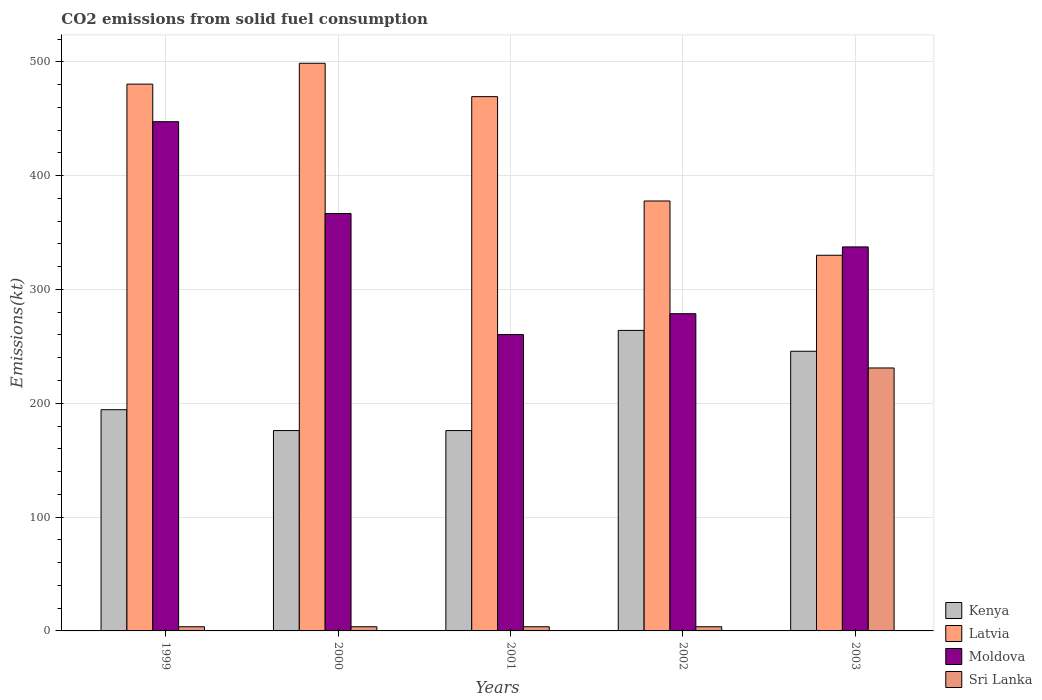Are the number of bars on each tick of the X-axis equal?
Offer a terse response. Yes. What is the label of the 5th group of bars from the left?
Provide a short and direct response. 2003. What is the amount of CO2 emitted in Kenya in 2001?
Make the answer very short. 176.02. Across all years, what is the maximum amount of CO2 emitted in Moldova?
Offer a terse response. 447.37. Across all years, what is the minimum amount of CO2 emitted in Latvia?
Keep it short and to the point. 330.03. In which year was the amount of CO2 emitted in Kenya maximum?
Your answer should be very brief. 2002. In which year was the amount of CO2 emitted in Kenya minimum?
Give a very brief answer. 2000. What is the total amount of CO2 emitted in Sri Lanka in the graph?
Provide a succinct answer. 245.69. What is the difference between the amount of CO2 emitted in Moldova in 2001 and that in 2003?
Your answer should be very brief. -77.01. What is the difference between the amount of CO2 emitted in Moldova in 2000 and the amount of CO2 emitted in Kenya in 2003?
Offer a terse response. 121.01. What is the average amount of CO2 emitted in Sri Lanka per year?
Give a very brief answer. 49.14. In the year 1999, what is the difference between the amount of CO2 emitted in Moldova and amount of CO2 emitted in Latvia?
Give a very brief answer. -33. What is the ratio of the amount of CO2 emitted in Moldova in 1999 to that in 2002?
Your answer should be compact. 1.61. What is the difference between the highest and the second highest amount of CO2 emitted in Kenya?
Offer a terse response. 18.34. What is the difference between the highest and the lowest amount of CO2 emitted in Sri Lanka?
Your answer should be very brief. 227.35. Is the sum of the amount of CO2 emitted in Moldova in 2002 and 2003 greater than the maximum amount of CO2 emitted in Kenya across all years?
Give a very brief answer. Yes. What does the 2nd bar from the left in 2002 represents?
Offer a very short reply. Latvia. What does the 2nd bar from the right in 2001 represents?
Keep it short and to the point. Moldova. Is it the case that in every year, the sum of the amount of CO2 emitted in Latvia and amount of CO2 emitted in Moldova is greater than the amount of CO2 emitted in Sri Lanka?
Your response must be concise. Yes. Are all the bars in the graph horizontal?
Offer a very short reply. No. What is the difference between two consecutive major ticks on the Y-axis?
Offer a terse response. 100. Are the values on the major ticks of Y-axis written in scientific E-notation?
Keep it short and to the point. No. What is the title of the graph?
Provide a short and direct response. CO2 emissions from solid fuel consumption. What is the label or title of the Y-axis?
Your answer should be very brief. Emissions(kt). What is the Emissions(kt) of Kenya in 1999?
Your response must be concise. 194.35. What is the Emissions(kt) in Latvia in 1999?
Offer a terse response. 480.38. What is the Emissions(kt) of Moldova in 1999?
Give a very brief answer. 447.37. What is the Emissions(kt) of Sri Lanka in 1999?
Offer a very short reply. 3.67. What is the Emissions(kt) of Kenya in 2000?
Provide a short and direct response. 176.02. What is the Emissions(kt) in Latvia in 2000?
Provide a succinct answer. 498.71. What is the Emissions(kt) in Moldova in 2000?
Give a very brief answer. 366.7. What is the Emissions(kt) in Sri Lanka in 2000?
Offer a terse response. 3.67. What is the Emissions(kt) of Kenya in 2001?
Offer a terse response. 176.02. What is the Emissions(kt) in Latvia in 2001?
Keep it short and to the point. 469.38. What is the Emissions(kt) in Moldova in 2001?
Offer a terse response. 260.36. What is the Emissions(kt) of Sri Lanka in 2001?
Give a very brief answer. 3.67. What is the Emissions(kt) of Kenya in 2002?
Keep it short and to the point. 264.02. What is the Emissions(kt) of Latvia in 2002?
Offer a terse response. 377.7. What is the Emissions(kt) of Moldova in 2002?
Offer a terse response. 278.69. What is the Emissions(kt) in Sri Lanka in 2002?
Give a very brief answer. 3.67. What is the Emissions(kt) in Kenya in 2003?
Provide a short and direct response. 245.69. What is the Emissions(kt) of Latvia in 2003?
Ensure brevity in your answer.  330.03. What is the Emissions(kt) in Moldova in 2003?
Provide a short and direct response. 337.36. What is the Emissions(kt) of Sri Lanka in 2003?
Provide a succinct answer. 231.02. Across all years, what is the maximum Emissions(kt) in Kenya?
Offer a very short reply. 264.02. Across all years, what is the maximum Emissions(kt) of Latvia?
Make the answer very short. 498.71. Across all years, what is the maximum Emissions(kt) in Moldova?
Keep it short and to the point. 447.37. Across all years, what is the maximum Emissions(kt) of Sri Lanka?
Offer a very short reply. 231.02. Across all years, what is the minimum Emissions(kt) of Kenya?
Give a very brief answer. 176.02. Across all years, what is the minimum Emissions(kt) of Latvia?
Offer a terse response. 330.03. Across all years, what is the minimum Emissions(kt) of Moldova?
Give a very brief answer. 260.36. Across all years, what is the minimum Emissions(kt) of Sri Lanka?
Make the answer very short. 3.67. What is the total Emissions(kt) of Kenya in the graph?
Offer a very short reply. 1056.1. What is the total Emissions(kt) of Latvia in the graph?
Make the answer very short. 2156.2. What is the total Emissions(kt) in Moldova in the graph?
Offer a terse response. 1690.49. What is the total Emissions(kt) in Sri Lanka in the graph?
Ensure brevity in your answer.  245.69. What is the difference between the Emissions(kt) of Kenya in 1999 and that in 2000?
Make the answer very short. 18.34. What is the difference between the Emissions(kt) of Latvia in 1999 and that in 2000?
Give a very brief answer. -18.34. What is the difference between the Emissions(kt) in Moldova in 1999 and that in 2000?
Your answer should be compact. 80.67. What is the difference between the Emissions(kt) of Kenya in 1999 and that in 2001?
Give a very brief answer. 18.34. What is the difference between the Emissions(kt) in Latvia in 1999 and that in 2001?
Ensure brevity in your answer.  11. What is the difference between the Emissions(kt) in Moldova in 1999 and that in 2001?
Your response must be concise. 187.02. What is the difference between the Emissions(kt) in Kenya in 1999 and that in 2002?
Provide a short and direct response. -69.67. What is the difference between the Emissions(kt) of Latvia in 1999 and that in 2002?
Offer a terse response. 102.68. What is the difference between the Emissions(kt) of Moldova in 1999 and that in 2002?
Ensure brevity in your answer.  168.68. What is the difference between the Emissions(kt) in Sri Lanka in 1999 and that in 2002?
Provide a succinct answer. 0. What is the difference between the Emissions(kt) in Kenya in 1999 and that in 2003?
Keep it short and to the point. -51.34. What is the difference between the Emissions(kt) of Latvia in 1999 and that in 2003?
Your response must be concise. 150.35. What is the difference between the Emissions(kt) in Moldova in 1999 and that in 2003?
Offer a terse response. 110.01. What is the difference between the Emissions(kt) in Sri Lanka in 1999 and that in 2003?
Your answer should be compact. -227.35. What is the difference between the Emissions(kt) of Latvia in 2000 and that in 2001?
Give a very brief answer. 29.34. What is the difference between the Emissions(kt) in Moldova in 2000 and that in 2001?
Provide a short and direct response. 106.34. What is the difference between the Emissions(kt) in Kenya in 2000 and that in 2002?
Offer a terse response. -88.01. What is the difference between the Emissions(kt) in Latvia in 2000 and that in 2002?
Your answer should be very brief. 121.01. What is the difference between the Emissions(kt) of Moldova in 2000 and that in 2002?
Offer a very short reply. 88.01. What is the difference between the Emissions(kt) in Sri Lanka in 2000 and that in 2002?
Your response must be concise. 0. What is the difference between the Emissions(kt) in Kenya in 2000 and that in 2003?
Your answer should be very brief. -69.67. What is the difference between the Emissions(kt) in Latvia in 2000 and that in 2003?
Your response must be concise. 168.68. What is the difference between the Emissions(kt) of Moldova in 2000 and that in 2003?
Your answer should be compact. 29.34. What is the difference between the Emissions(kt) of Sri Lanka in 2000 and that in 2003?
Give a very brief answer. -227.35. What is the difference between the Emissions(kt) of Kenya in 2001 and that in 2002?
Keep it short and to the point. -88.01. What is the difference between the Emissions(kt) of Latvia in 2001 and that in 2002?
Your response must be concise. 91.67. What is the difference between the Emissions(kt) of Moldova in 2001 and that in 2002?
Give a very brief answer. -18.34. What is the difference between the Emissions(kt) of Kenya in 2001 and that in 2003?
Make the answer very short. -69.67. What is the difference between the Emissions(kt) of Latvia in 2001 and that in 2003?
Offer a terse response. 139.35. What is the difference between the Emissions(kt) in Moldova in 2001 and that in 2003?
Your response must be concise. -77.01. What is the difference between the Emissions(kt) of Sri Lanka in 2001 and that in 2003?
Your answer should be compact. -227.35. What is the difference between the Emissions(kt) in Kenya in 2002 and that in 2003?
Provide a succinct answer. 18.34. What is the difference between the Emissions(kt) in Latvia in 2002 and that in 2003?
Provide a short and direct response. 47.67. What is the difference between the Emissions(kt) in Moldova in 2002 and that in 2003?
Make the answer very short. -58.67. What is the difference between the Emissions(kt) in Sri Lanka in 2002 and that in 2003?
Your answer should be very brief. -227.35. What is the difference between the Emissions(kt) of Kenya in 1999 and the Emissions(kt) of Latvia in 2000?
Provide a short and direct response. -304.36. What is the difference between the Emissions(kt) of Kenya in 1999 and the Emissions(kt) of Moldova in 2000?
Offer a terse response. -172.35. What is the difference between the Emissions(kt) of Kenya in 1999 and the Emissions(kt) of Sri Lanka in 2000?
Ensure brevity in your answer.  190.68. What is the difference between the Emissions(kt) of Latvia in 1999 and the Emissions(kt) of Moldova in 2000?
Offer a terse response. 113.68. What is the difference between the Emissions(kt) of Latvia in 1999 and the Emissions(kt) of Sri Lanka in 2000?
Provide a short and direct response. 476.71. What is the difference between the Emissions(kt) in Moldova in 1999 and the Emissions(kt) in Sri Lanka in 2000?
Give a very brief answer. 443.71. What is the difference between the Emissions(kt) of Kenya in 1999 and the Emissions(kt) of Latvia in 2001?
Ensure brevity in your answer.  -275.02. What is the difference between the Emissions(kt) of Kenya in 1999 and the Emissions(kt) of Moldova in 2001?
Your answer should be very brief. -66.01. What is the difference between the Emissions(kt) of Kenya in 1999 and the Emissions(kt) of Sri Lanka in 2001?
Your answer should be very brief. 190.68. What is the difference between the Emissions(kt) of Latvia in 1999 and the Emissions(kt) of Moldova in 2001?
Offer a terse response. 220.02. What is the difference between the Emissions(kt) of Latvia in 1999 and the Emissions(kt) of Sri Lanka in 2001?
Provide a succinct answer. 476.71. What is the difference between the Emissions(kt) of Moldova in 1999 and the Emissions(kt) of Sri Lanka in 2001?
Make the answer very short. 443.71. What is the difference between the Emissions(kt) of Kenya in 1999 and the Emissions(kt) of Latvia in 2002?
Offer a terse response. -183.35. What is the difference between the Emissions(kt) of Kenya in 1999 and the Emissions(kt) of Moldova in 2002?
Ensure brevity in your answer.  -84.34. What is the difference between the Emissions(kt) of Kenya in 1999 and the Emissions(kt) of Sri Lanka in 2002?
Ensure brevity in your answer.  190.68. What is the difference between the Emissions(kt) of Latvia in 1999 and the Emissions(kt) of Moldova in 2002?
Offer a very short reply. 201.69. What is the difference between the Emissions(kt) of Latvia in 1999 and the Emissions(kt) of Sri Lanka in 2002?
Your response must be concise. 476.71. What is the difference between the Emissions(kt) in Moldova in 1999 and the Emissions(kt) in Sri Lanka in 2002?
Make the answer very short. 443.71. What is the difference between the Emissions(kt) in Kenya in 1999 and the Emissions(kt) in Latvia in 2003?
Ensure brevity in your answer.  -135.68. What is the difference between the Emissions(kt) in Kenya in 1999 and the Emissions(kt) in Moldova in 2003?
Offer a very short reply. -143.01. What is the difference between the Emissions(kt) in Kenya in 1999 and the Emissions(kt) in Sri Lanka in 2003?
Your response must be concise. -36.67. What is the difference between the Emissions(kt) in Latvia in 1999 and the Emissions(kt) in Moldova in 2003?
Make the answer very short. 143.01. What is the difference between the Emissions(kt) in Latvia in 1999 and the Emissions(kt) in Sri Lanka in 2003?
Keep it short and to the point. 249.36. What is the difference between the Emissions(kt) of Moldova in 1999 and the Emissions(kt) of Sri Lanka in 2003?
Your answer should be very brief. 216.35. What is the difference between the Emissions(kt) in Kenya in 2000 and the Emissions(kt) in Latvia in 2001?
Your answer should be compact. -293.36. What is the difference between the Emissions(kt) in Kenya in 2000 and the Emissions(kt) in Moldova in 2001?
Provide a short and direct response. -84.34. What is the difference between the Emissions(kt) in Kenya in 2000 and the Emissions(kt) in Sri Lanka in 2001?
Your answer should be very brief. 172.35. What is the difference between the Emissions(kt) of Latvia in 2000 and the Emissions(kt) of Moldova in 2001?
Your response must be concise. 238.35. What is the difference between the Emissions(kt) of Latvia in 2000 and the Emissions(kt) of Sri Lanka in 2001?
Your response must be concise. 495.05. What is the difference between the Emissions(kt) in Moldova in 2000 and the Emissions(kt) in Sri Lanka in 2001?
Your response must be concise. 363.03. What is the difference between the Emissions(kt) of Kenya in 2000 and the Emissions(kt) of Latvia in 2002?
Make the answer very short. -201.69. What is the difference between the Emissions(kt) in Kenya in 2000 and the Emissions(kt) in Moldova in 2002?
Offer a terse response. -102.68. What is the difference between the Emissions(kt) in Kenya in 2000 and the Emissions(kt) in Sri Lanka in 2002?
Your answer should be compact. 172.35. What is the difference between the Emissions(kt) of Latvia in 2000 and the Emissions(kt) of Moldova in 2002?
Give a very brief answer. 220.02. What is the difference between the Emissions(kt) in Latvia in 2000 and the Emissions(kt) in Sri Lanka in 2002?
Make the answer very short. 495.05. What is the difference between the Emissions(kt) in Moldova in 2000 and the Emissions(kt) in Sri Lanka in 2002?
Your answer should be compact. 363.03. What is the difference between the Emissions(kt) in Kenya in 2000 and the Emissions(kt) in Latvia in 2003?
Ensure brevity in your answer.  -154.01. What is the difference between the Emissions(kt) of Kenya in 2000 and the Emissions(kt) of Moldova in 2003?
Give a very brief answer. -161.35. What is the difference between the Emissions(kt) of Kenya in 2000 and the Emissions(kt) of Sri Lanka in 2003?
Your response must be concise. -55.01. What is the difference between the Emissions(kt) of Latvia in 2000 and the Emissions(kt) of Moldova in 2003?
Give a very brief answer. 161.35. What is the difference between the Emissions(kt) in Latvia in 2000 and the Emissions(kt) in Sri Lanka in 2003?
Make the answer very short. 267.69. What is the difference between the Emissions(kt) of Moldova in 2000 and the Emissions(kt) of Sri Lanka in 2003?
Keep it short and to the point. 135.68. What is the difference between the Emissions(kt) of Kenya in 2001 and the Emissions(kt) of Latvia in 2002?
Offer a very short reply. -201.69. What is the difference between the Emissions(kt) of Kenya in 2001 and the Emissions(kt) of Moldova in 2002?
Provide a short and direct response. -102.68. What is the difference between the Emissions(kt) of Kenya in 2001 and the Emissions(kt) of Sri Lanka in 2002?
Make the answer very short. 172.35. What is the difference between the Emissions(kt) of Latvia in 2001 and the Emissions(kt) of Moldova in 2002?
Your answer should be very brief. 190.68. What is the difference between the Emissions(kt) of Latvia in 2001 and the Emissions(kt) of Sri Lanka in 2002?
Provide a succinct answer. 465.71. What is the difference between the Emissions(kt) of Moldova in 2001 and the Emissions(kt) of Sri Lanka in 2002?
Keep it short and to the point. 256.69. What is the difference between the Emissions(kt) in Kenya in 2001 and the Emissions(kt) in Latvia in 2003?
Provide a short and direct response. -154.01. What is the difference between the Emissions(kt) in Kenya in 2001 and the Emissions(kt) in Moldova in 2003?
Give a very brief answer. -161.35. What is the difference between the Emissions(kt) in Kenya in 2001 and the Emissions(kt) in Sri Lanka in 2003?
Make the answer very short. -55.01. What is the difference between the Emissions(kt) in Latvia in 2001 and the Emissions(kt) in Moldova in 2003?
Your response must be concise. 132.01. What is the difference between the Emissions(kt) in Latvia in 2001 and the Emissions(kt) in Sri Lanka in 2003?
Give a very brief answer. 238.35. What is the difference between the Emissions(kt) in Moldova in 2001 and the Emissions(kt) in Sri Lanka in 2003?
Provide a succinct answer. 29.34. What is the difference between the Emissions(kt) in Kenya in 2002 and the Emissions(kt) in Latvia in 2003?
Offer a terse response. -66.01. What is the difference between the Emissions(kt) in Kenya in 2002 and the Emissions(kt) in Moldova in 2003?
Offer a very short reply. -73.34. What is the difference between the Emissions(kt) in Kenya in 2002 and the Emissions(kt) in Sri Lanka in 2003?
Ensure brevity in your answer.  33. What is the difference between the Emissions(kt) of Latvia in 2002 and the Emissions(kt) of Moldova in 2003?
Your answer should be compact. 40.34. What is the difference between the Emissions(kt) of Latvia in 2002 and the Emissions(kt) of Sri Lanka in 2003?
Your response must be concise. 146.68. What is the difference between the Emissions(kt) of Moldova in 2002 and the Emissions(kt) of Sri Lanka in 2003?
Keep it short and to the point. 47.67. What is the average Emissions(kt) of Kenya per year?
Your response must be concise. 211.22. What is the average Emissions(kt) of Latvia per year?
Make the answer very short. 431.24. What is the average Emissions(kt) in Moldova per year?
Keep it short and to the point. 338.1. What is the average Emissions(kt) in Sri Lanka per year?
Ensure brevity in your answer.  49.14. In the year 1999, what is the difference between the Emissions(kt) in Kenya and Emissions(kt) in Latvia?
Ensure brevity in your answer.  -286.03. In the year 1999, what is the difference between the Emissions(kt) of Kenya and Emissions(kt) of Moldova?
Your answer should be compact. -253.02. In the year 1999, what is the difference between the Emissions(kt) of Kenya and Emissions(kt) of Sri Lanka?
Your response must be concise. 190.68. In the year 1999, what is the difference between the Emissions(kt) in Latvia and Emissions(kt) in Moldova?
Offer a terse response. 33. In the year 1999, what is the difference between the Emissions(kt) of Latvia and Emissions(kt) of Sri Lanka?
Offer a very short reply. 476.71. In the year 1999, what is the difference between the Emissions(kt) of Moldova and Emissions(kt) of Sri Lanka?
Give a very brief answer. 443.71. In the year 2000, what is the difference between the Emissions(kt) of Kenya and Emissions(kt) of Latvia?
Provide a short and direct response. -322.7. In the year 2000, what is the difference between the Emissions(kt) in Kenya and Emissions(kt) in Moldova?
Keep it short and to the point. -190.68. In the year 2000, what is the difference between the Emissions(kt) in Kenya and Emissions(kt) in Sri Lanka?
Offer a very short reply. 172.35. In the year 2000, what is the difference between the Emissions(kt) in Latvia and Emissions(kt) in Moldova?
Keep it short and to the point. 132.01. In the year 2000, what is the difference between the Emissions(kt) of Latvia and Emissions(kt) of Sri Lanka?
Provide a succinct answer. 495.05. In the year 2000, what is the difference between the Emissions(kt) of Moldova and Emissions(kt) of Sri Lanka?
Offer a very short reply. 363.03. In the year 2001, what is the difference between the Emissions(kt) in Kenya and Emissions(kt) in Latvia?
Make the answer very short. -293.36. In the year 2001, what is the difference between the Emissions(kt) of Kenya and Emissions(kt) of Moldova?
Make the answer very short. -84.34. In the year 2001, what is the difference between the Emissions(kt) in Kenya and Emissions(kt) in Sri Lanka?
Offer a terse response. 172.35. In the year 2001, what is the difference between the Emissions(kt) in Latvia and Emissions(kt) in Moldova?
Your response must be concise. 209.02. In the year 2001, what is the difference between the Emissions(kt) in Latvia and Emissions(kt) in Sri Lanka?
Provide a succinct answer. 465.71. In the year 2001, what is the difference between the Emissions(kt) of Moldova and Emissions(kt) of Sri Lanka?
Keep it short and to the point. 256.69. In the year 2002, what is the difference between the Emissions(kt) of Kenya and Emissions(kt) of Latvia?
Offer a terse response. -113.68. In the year 2002, what is the difference between the Emissions(kt) of Kenya and Emissions(kt) of Moldova?
Offer a very short reply. -14.67. In the year 2002, what is the difference between the Emissions(kt) of Kenya and Emissions(kt) of Sri Lanka?
Your response must be concise. 260.36. In the year 2002, what is the difference between the Emissions(kt) in Latvia and Emissions(kt) in Moldova?
Provide a short and direct response. 99.01. In the year 2002, what is the difference between the Emissions(kt) of Latvia and Emissions(kt) of Sri Lanka?
Make the answer very short. 374.03. In the year 2002, what is the difference between the Emissions(kt) in Moldova and Emissions(kt) in Sri Lanka?
Provide a succinct answer. 275.02. In the year 2003, what is the difference between the Emissions(kt) of Kenya and Emissions(kt) of Latvia?
Your answer should be compact. -84.34. In the year 2003, what is the difference between the Emissions(kt) of Kenya and Emissions(kt) of Moldova?
Ensure brevity in your answer.  -91.67. In the year 2003, what is the difference between the Emissions(kt) in Kenya and Emissions(kt) in Sri Lanka?
Ensure brevity in your answer.  14.67. In the year 2003, what is the difference between the Emissions(kt) in Latvia and Emissions(kt) in Moldova?
Your answer should be compact. -7.33. In the year 2003, what is the difference between the Emissions(kt) of Latvia and Emissions(kt) of Sri Lanka?
Offer a very short reply. 99.01. In the year 2003, what is the difference between the Emissions(kt) of Moldova and Emissions(kt) of Sri Lanka?
Offer a very short reply. 106.34. What is the ratio of the Emissions(kt) in Kenya in 1999 to that in 2000?
Your answer should be very brief. 1.1. What is the ratio of the Emissions(kt) of Latvia in 1999 to that in 2000?
Give a very brief answer. 0.96. What is the ratio of the Emissions(kt) of Moldova in 1999 to that in 2000?
Ensure brevity in your answer.  1.22. What is the ratio of the Emissions(kt) of Kenya in 1999 to that in 2001?
Keep it short and to the point. 1.1. What is the ratio of the Emissions(kt) in Latvia in 1999 to that in 2001?
Keep it short and to the point. 1.02. What is the ratio of the Emissions(kt) of Moldova in 1999 to that in 2001?
Ensure brevity in your answer.  1.72. What is the ratio of the Emissions(kt) in Kenya in 1999 to that in 2002?
Keep it short and to the point. 0.74. What is the ratio of the Emissions(kt) of Latvia in 1999 to that in 2002?
Make the answer very short. 1.27. What is the ratio of the Emissions(kt) in Moldova in 1999 to that in 2002?
Your answer should be very brief. 1.61. What is the ratio of the Emissions(kt) in Kenya in 1999 to that in 2003?
Your answer should be very brief. 0.79. What is the ratio of the Emissions(kt) of Latvia in 1999 to that in 2003?
Give a very brief answer. 1.46. What is the ratio of the Emissions(kt) of Moldova in 1999 to that in 2003?
Your answer should be compact. 1.33. What is the ratio of the Emissions(kt) in Sri Lanka in 1999 to that in 2003?
Your response must be concise. 0.02. What is the ratio of the Emissions(kt) in Moldova in 2000 to that in 2001?
Your response must be concise. 1.41. What is the ratio of the Emissions(kt) in Kenya in 2000 to that in 2002?
Offer a terse response. 0.67. What is the ratio of the Emissions(kt) of Latvia in 2000 to that in 2002?
Provide a short and direct response. 1.32. What is the ratio of the Emissions(kt) in Moldova in 2000 to that in 2002?
Offer a terse response. 1.32. What is the ratio of the Emissions(kt) in Sri Lanka in 2000 to that in 2002?
Your answer should be very brief. 1. What is the ratio of the Emissions(kt) of Kenya in 2000 to that in 2003?
Offer a terse response. 0.72. What is the ratio of the Emissions(kt) of Latvia in 2000 to that in 2003?
Make the answer very short. 1.51. What is the ratio of the Emissions(kt) in Moldova in 2000 to that in 2003?
Give a very brief answer. 1.09. What is the ratio of the Emissions(kt) in Sri Lanka in 2000 to that in 2003?
Provide a succinct answer. 0.02. What is the ratio of the Emissions(kt) of Latvia in 2001 to that in 2002?
Provide a succinct answer. 1.24. What is the ratio of the Emissions(kt) of Moldova in 2001 to that in 2002?
Make the answer very short. 0.93. What is the ratio of the Emissions(kt) of Kenya in 2001 to that in 2003?
Make the answer very short. 0.72. What is the ratio of the Emissions(kt) of Latvia in 2001 to that in 2003?
Make the answer very short. 1.42. What is the ratio of the Emissions(kt) of Moldova in 2001 to that in 2003?
Your response must be concise. 0.77. What is the ratio of the Emissions(kt) of Sri Lanka in 2001 to that in 2003?
Your answer should be very brief. 0.02. What is the ratio of the Emissions(kt) of Kenya in 2002 to that in 2003?
Provide a succinct answer. 1.07. What is the ratio of the Emissions(kt) of Latvia in 2002 to that in 2003?
Ensure brevity in your answer.  1.14. What is the ratio of the Emissions(kt) of Moldova in 2002 to that in 2003?
Your response must be concise. 0.83. What is the ratio of the Emissions(kt) in Sri Lanka in 2002 to that in 2003?
Your response must be concise. 0.02. What is the difference between the highest and the second highest Emissions(kt) of Kenya?
Provide a short and direct response. 18.34. What is the difference between the highest and the second highest Emissions(kt) in Latvia?
Offer a very short reply. 18.34. What is the difference between the highest and the second highest Emissions(kt) in Moldova?
Provide a short and direct response. 80.67. What is the difference between the highest and the second highest Emissions(kt) of Sri Lanka?
Offer a very short reply. 227.35. What is the difference between the highest and the lowest Emissions(kt) of Kenya?
Make the answer very short. 88.01. What is the difference between the highest and the lowest Emissions(kt) in Latvia?
Make the answer very short. 168.68. What is the difference between the highest and the lowest Emissions(kt) in Moldova?
Your answer should be compact. 187.02. What is the difference between the highest and the lowest Emissions(kt) of Sri Lanka?
Make the answer very short. 227.35. 